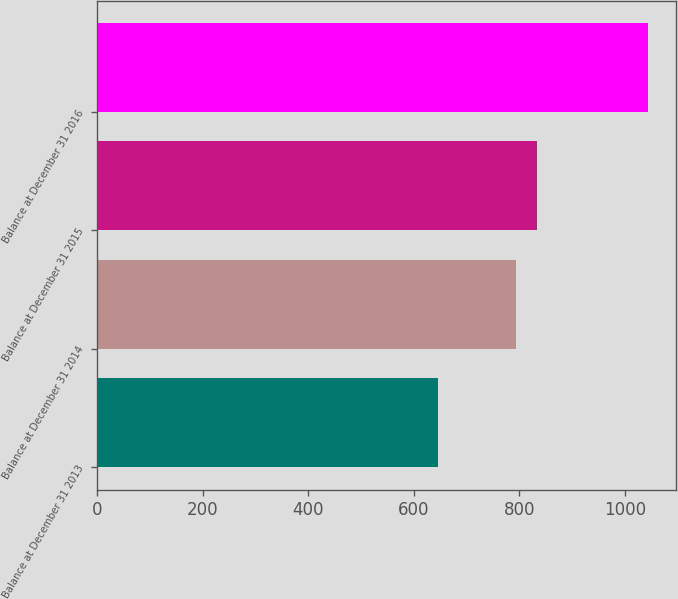Convert chart to OTSL. <chart><loc_0><loc_0><loc_500><loc_500><bar_chart><fcel>Balance at December 31 2013<fcel>Balance at December 31 2014<fcel>Balance at December 31 2015<fcel>Balance at December 31 2016<nl><fcel>645.2<fcel>794.4<fcel>834.36<fcel>1044.8<nl></chart> 